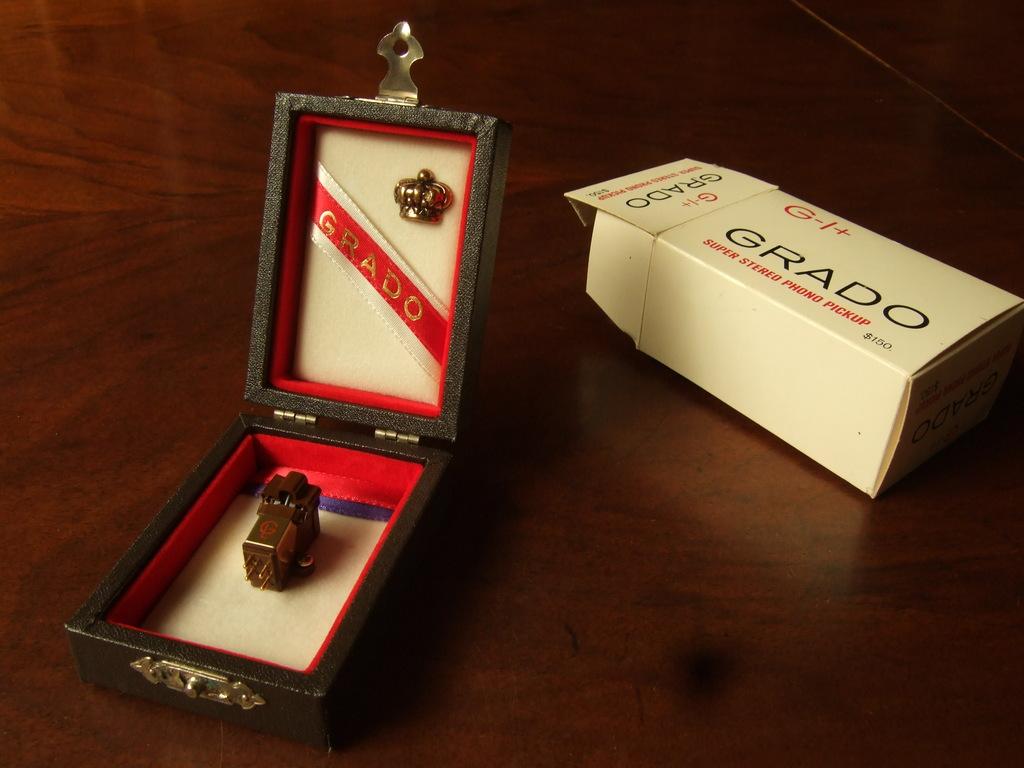What is that?
Your answer should be compact. Super stereo phono pickup. What brand is this?
Provide a short and direct response. Grado. 